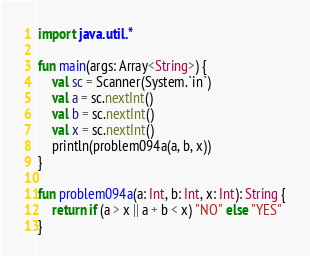<code> <loc_0><loc_0><loc_500><loc_500><_Kotlin_>import java.util.*

fun main(args: Array<String>) {
    val sc = Scanner(System.`in`)
    val a = sc.nextInt()
    val b = sc.nextInt()
    val x = sc.nextInt()
    println(problem094a(a, b, x))
}

fun problem094a(a: Int, b: Int, x: Int): String {
    return if (a > x || a + b < x) "NO" else "YES"
}</code> 